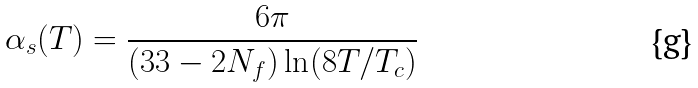<formula> <loc_0><loc_0><loc_500><loc_500>\alpha _ { s } ( T ) = \frac { 6 \pi } { ( 3 3 - 2 N _ { f } ) \ln ( 8 T / T _ { c } ) }</formula> 